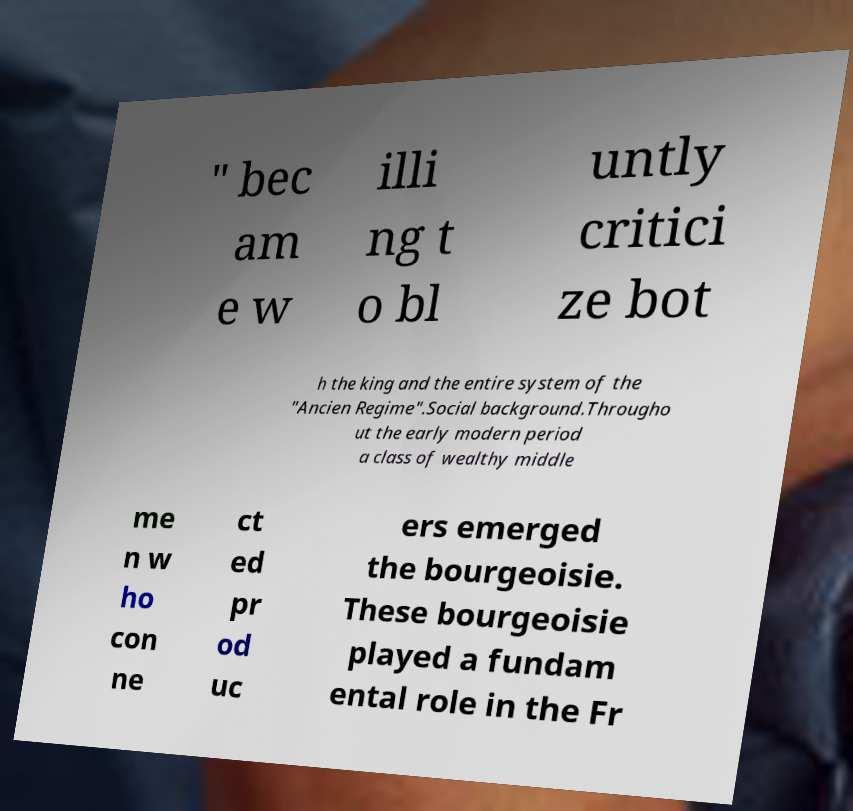Please identify and transcribe the text found in this image. " bec am e w illi ng t o bl untly critici ze bot h the king and the entire system of the "Ancien Regime".Social background.Througho ut the early modern period a class of wealthy middle me n w ho con ne ct ed pr od uc ers emerged the bourgeoisie. These bourgeoisie played a fundam ental role in the Fr 